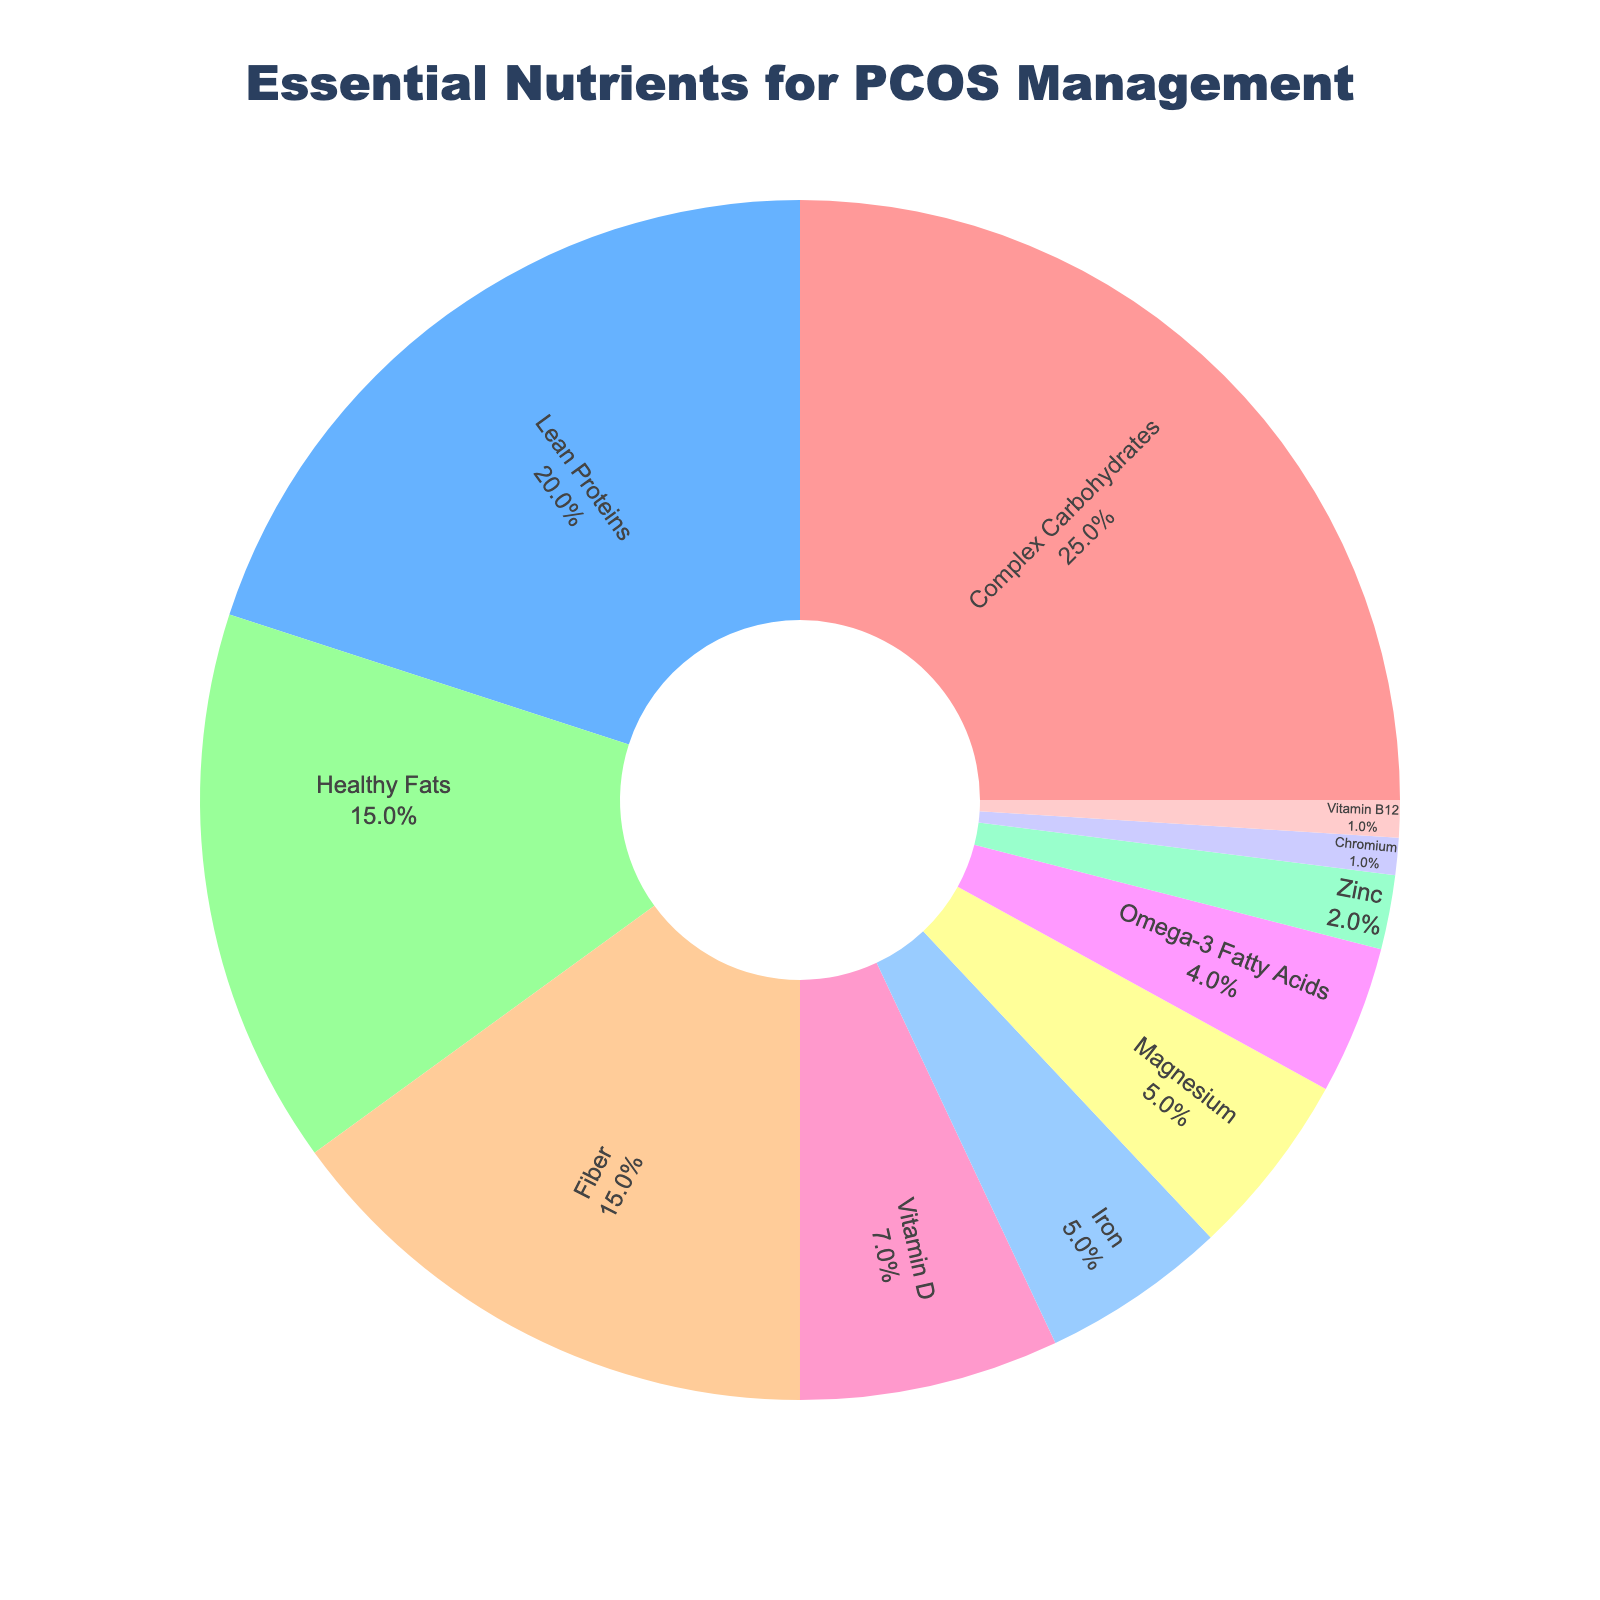What nutrient has the highest percentage in this meal plan? The nutrient with the highest percentage can be identified by looking at the largest segment in the pie chart. The segment labeled "Complex Carbohydrates" takes up the largest portion of the pie chart.
Answer: Complex Carbohydrates How much more percentage does Lean Proteins have compared to Omega-3 Fatty Acids? First, identify the percentage values of Lean Proteins (20%) and Omega-3 Fatty Acids (4%) from the chart. Then, calculate the difference: 20% - 4% = 16%.
Answer: 16% What's the combined percentage of Fiber and Vitamin D in this meal plan? Add the percentages of Fiber (15%) and Vitamin D (7%) together: 15% + 7% = 22%.
Answer: 22% Which nutrient has a lower percentage: Magnesium or Iron? Compare the segments labeled "Magnesium" (5%) and "Iron" (5%). Both segments represent the same percentage.
Answer: They are equal Is Chromium or Vitamin B12 allocated a higher percentage? Look at the pie chart segments for Chromium (1%) and Vitamin B12 (1%). Both nutrients have the same percentage.
Answer: They are equal What is the total percentage of nutrients in the pie chart categorized as vitamins and minerals? Sum of the nutrients categorized as vitamins and minerals: Vitamin D (7%) + Iron (5%) + Magnesium (5%) + Zinc (2%) + Chromium (1%) + Vitamin B12 (1%) = 21%.
Answer: 21% What is the combined percentage of Healthy Fats, Fiber, and Omega-3 Fatty Acids? Add the percentages of Healthy Fats (15%), Fiber (15%), and Omega-3 Fatty Acids (4%): 15% + 15% + 4% = 34%.
Answer: 34% Which color represents the Lean Proteins segment? Locate the segment labeled "Lean Proteins" and note its color. The Lean Proteins segment is represented by the blue-colored segment.
Answer: Blue Is the percentage of Fiber larger, smaller, or equal to the percentage of Healthy Fats? Compare the percentages of Fiber (15%) and Healthy Fats (15%). They are equal.
Answer: Equal Which two nutrients together make up 10% of the meal plan? Identify two nutrients whose combined percentages equal 10%. Zinc (2%) and Iron (5%) add up to 7%, which isn't sufficient. Looking at Iron (5%) and Magnesium (5%) add up to 10%.
Answer: Iron and Magnesium 